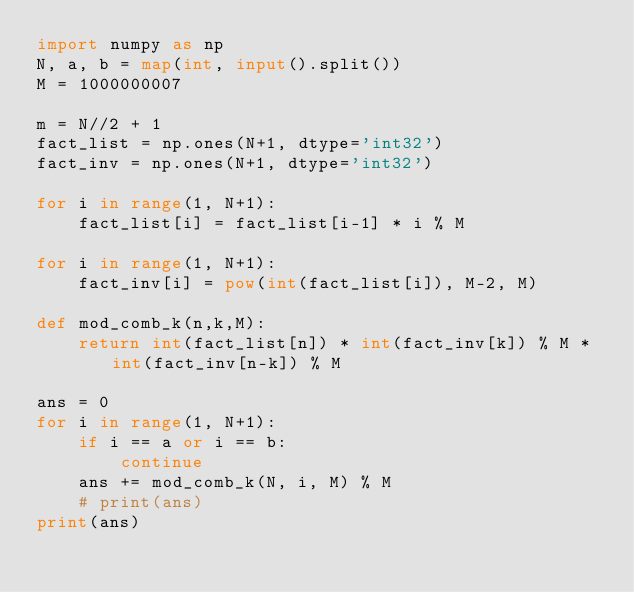Convert code to text. <code><loc_0><loc_0><loc_500><loc_500><_Python_>import numpy as np
N, a, b = map(int, input().split())
M = 1000000007

m = N//2 + 1
fact_list = np.ones(N+1, dtype='int32')
fact_inv = np.ones(N+1, dtype='int32')

for i in range(1, N+1):
    fact_list[i] = fact_list[i-1] * i % M

for i in range(1, N+1):
    fact_inv[i] = pow(int(fact_list[i]), M-2, M)

def mod_comb_k(n,k,M):
    return int(fact_list[n]) * int(fact_inv[k]) % M * int(fact_inv[n-k]) % M

ans = 0
for i in range(1, N+1):
    if i == a or i == b:
        continue
    ans += mod_comb_k(N, i, M) % M
    # print(ans)
print(ans)






</code> 